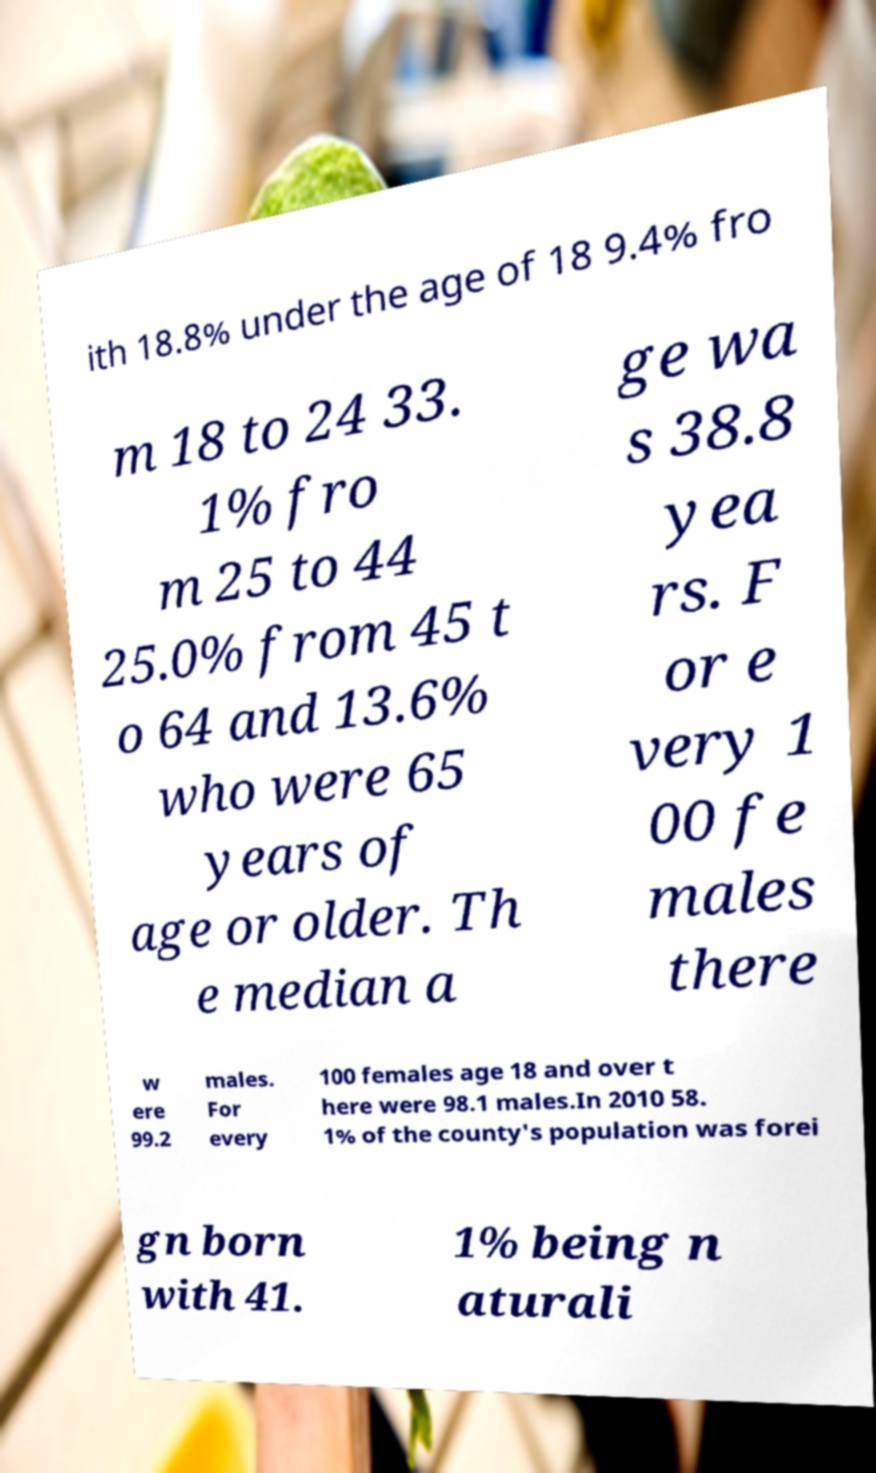What messages or text are displayed in this image? I need them in a readable, typed format. ith 18.8% under the age of 18 9.4% fro m 18 to 24 33. 1% fro m 25 to 44 25.0% from 45 t o 64 and 13.6% who were 65 years of age or older. Th e median a ge wa s 38.8 yea rs. F or e very 1 00 fe males there w ere 99.2 males. For every 100 females age 18 and over t here were 98.1 males.In 2010 58. 1% of the county's population was forei gn born with 41. 1% being n aturali 